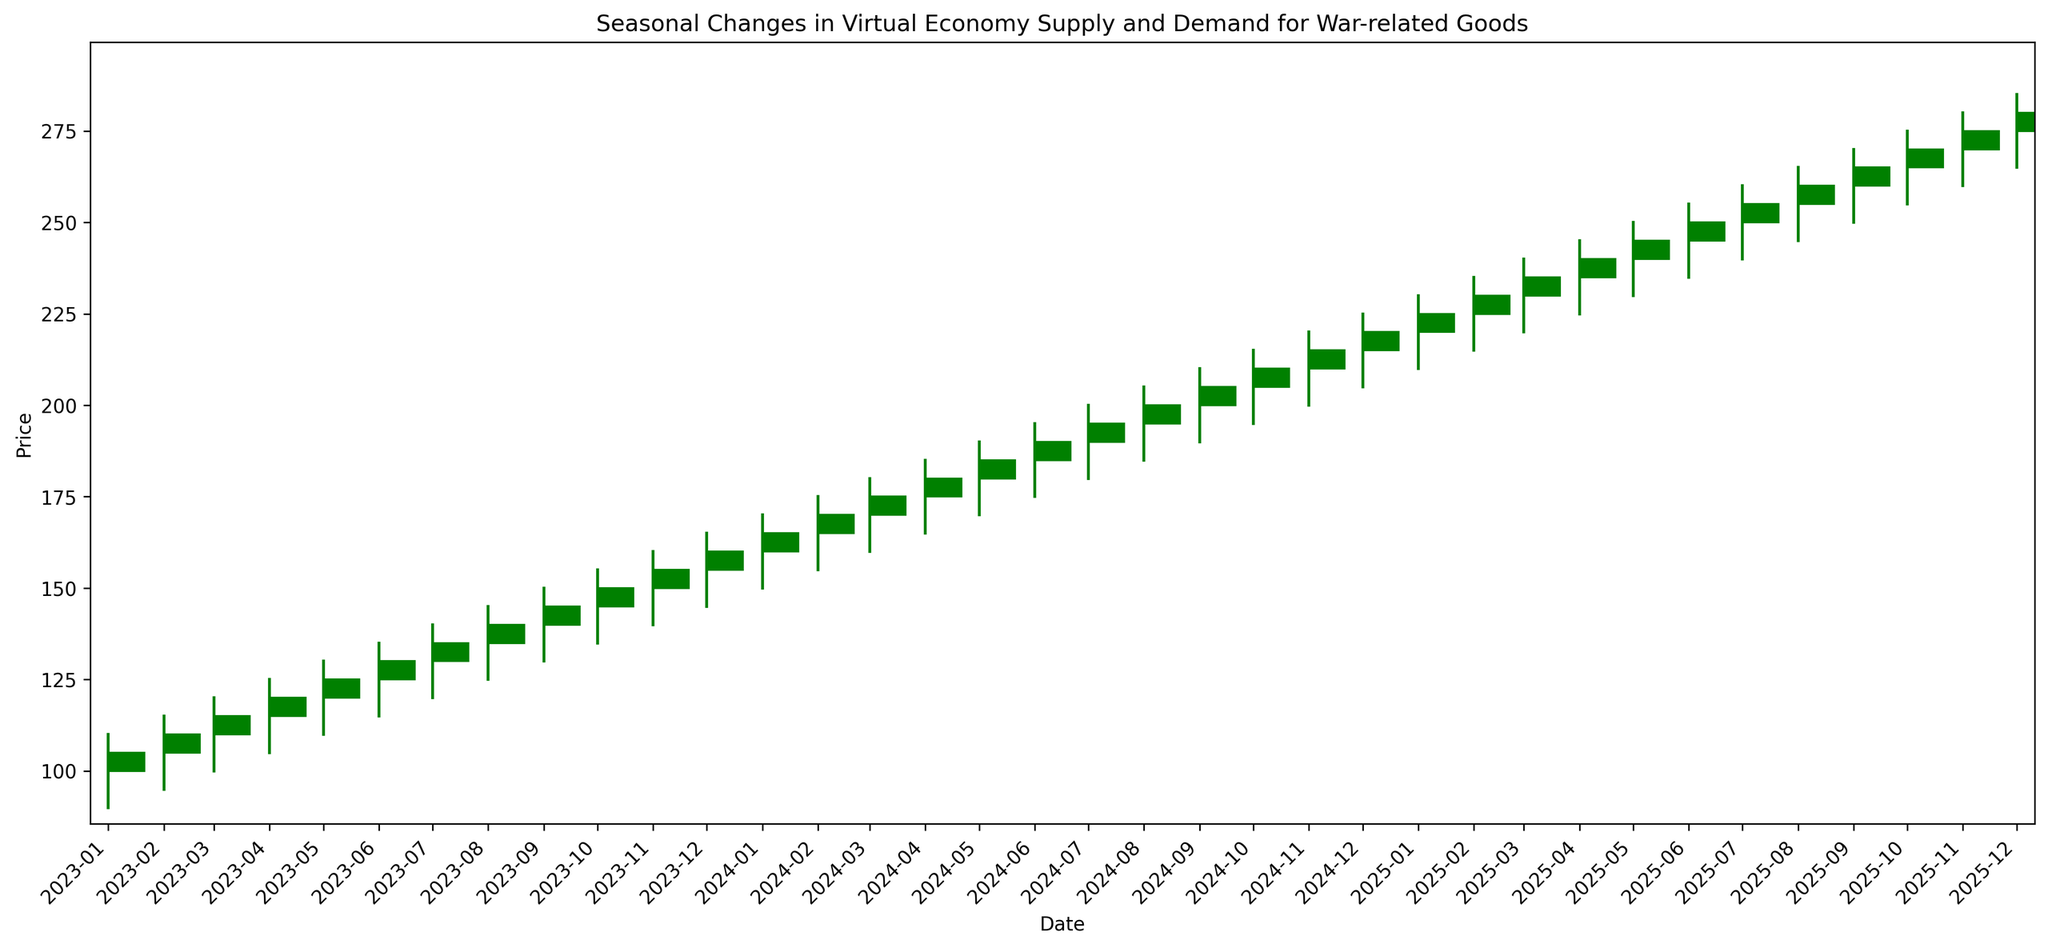Which month showed the highest closing price overall? The highest closing price overall appears at the end of the time series on the candlestick chart. The month with the highest closing price will therefore be the last month on the x-axis.
Answer: December 2025 Which two consecutive months had the largest increase in closing price? To find the two consecutive months with the largest increase in closing price, we need to look for the biggest green candlestick, which visually represents the largest jump in closing prices. Examine each pair of months and compare the height of the green candlesticks.
Answer: January 2024 to February 2024 Did any month close at a lower price than it opened? If so, which one(s)? To find months where the closing price was lower than the opening price, look for red candlesticks, which indicate a decrease in the closing price compared to the opening price.
Answer: No During which months did the price decrease the most? To determine the month with the highest decrease, identify the largest red candlestick, as this visually indicates the greatest reduction from opening to closing price. Since no red candlesticks are present, look for a month-to-month decline that results in a lower closing price.
Answer: N/A Which quarter (3-month period) showed the most significant overall increase in closing prices? Divide the chart into 4 quarters for each year and sum the closing prices for these periods. Compare the total increases for each quarter. The quarter with the highest sum increase in closing prices represents the period with the most significant growth.
Answer: Q1 2024 How does the closing price in December 2024 compare to the closing price in June 2025? Locate December 2024 and June 2025 on the x-axis, then compare their respective closing prices by observing the top of the candlesticks.
Answer: December 2024 > June 2025 What is the average closing price for the year 2023? Add all the closing prices for each month from January 2023 to December 2023 and divide the total by 12 to get the average. The sum of the closing prices is 105 + 110 + 115 + 120 + 125 + 130 + 135 + 140 + 145 + 150 + 155 + 160 = 1590. Divide by 12 for the average.
Answer: 132.5 Which month has the smallest range between the high and low prices? The range between high and low prices can be visually assessed by the length of the vertical lines above and below the candlesticks. Identify the month with the shortest line to find the smallest range.
Answer: January 2023 Are there any patterns noticeable in the price changes from year to year? To identify patterns, observe the trajectory of the candlesticks year over year. Notice if there's a consistent trend such as increasing prices every few months or notable repetitions.
Answer: Consistent increase What is the second highest high price recorded in the entire period? Identify the highest "High" prices visually by locating the highest points of the candlestick wicks and noting these. The second highest is just below the maximum high.
Answer: 280 